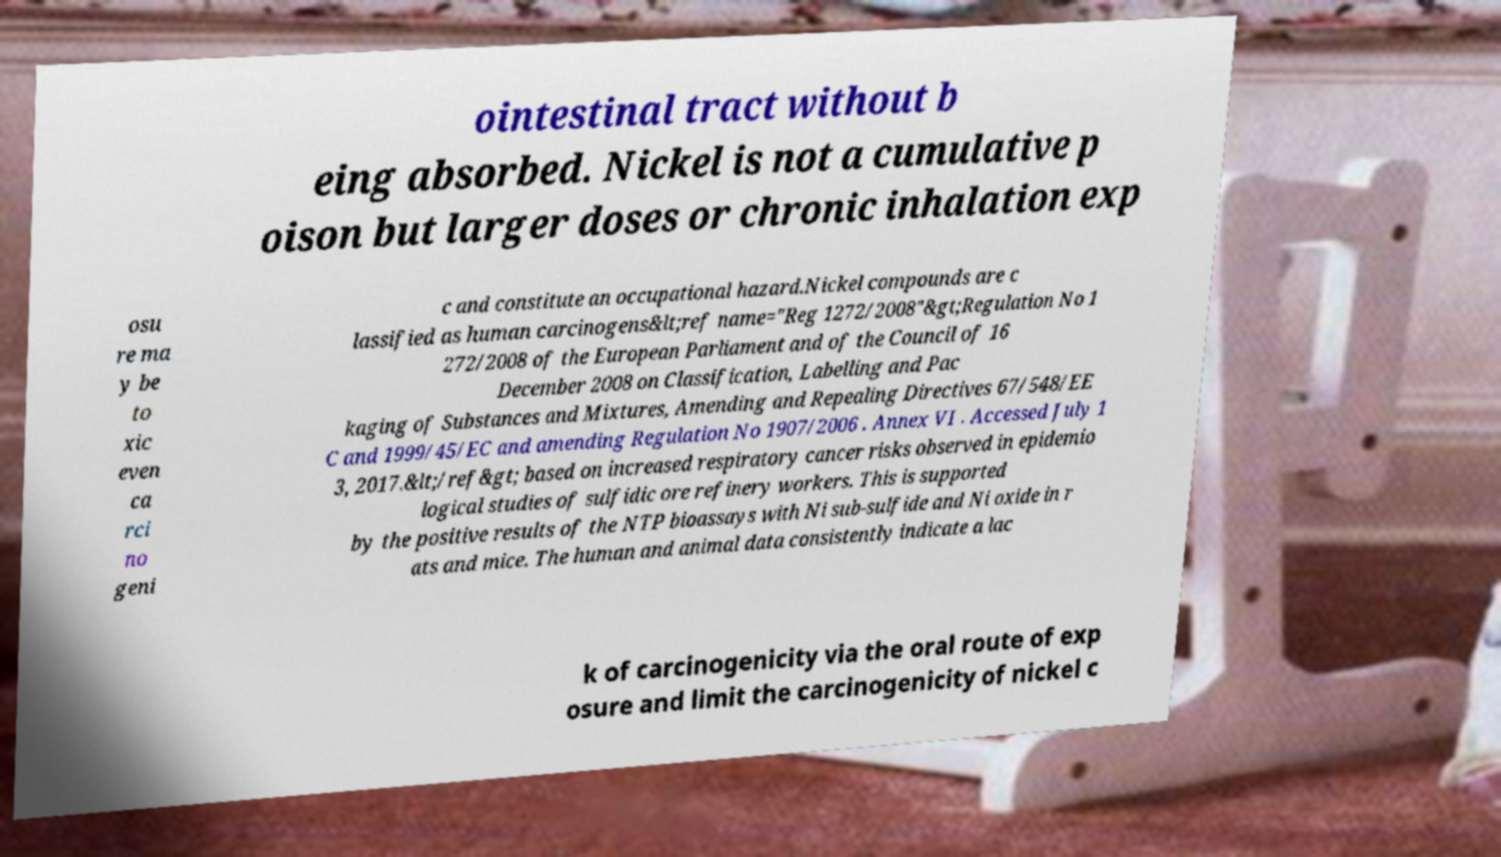For documentation purposes, I need the text within this image transcribed. Could you provide that? ointestinal tract without b eing absorbed. Nickel is not a cumulative p oison but larger doses or chronic inhalation exp osu re ma y be to xic even ca rci no geni c and constitute an occupational hazard.Nickel compounds are c lassified as human carcinogens&lt;ref name="Reg 1272/2008"&gt;Regulation No 1 272/2008 of the European Parliament and of the Council of 16 December 2008 on Classification, Labelling and Pac kaging of Substances and Mixtures, Amending and Repealing Directives 67/548/EE C and 1999/45/EC and amending Regulation No 1907/2006 . Annex VI . Accessed July 1 3, 2017.&lt;/ref&gt; based on increased respiratory cancer risks observed in epidemio logical studies of sulfidic ore refinery workers. This is supported by the positive results of the NTP bioassays with Ni sub-sulfide and Ni oxide in r ats and mice. The human and animal data consistently indicate a lac k of carcinogenicity via the oral route of exp osure and limit the carcinogenicity of nickel c 